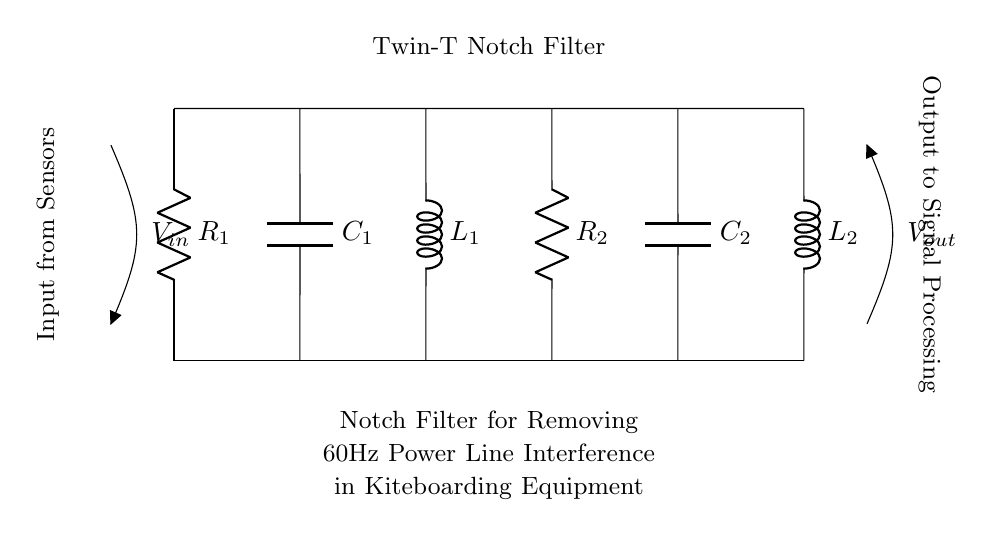What is the total number of components in the circuit? The circuit schematic shows six components: two resistors (R1, R2), two capacitors (C1, C2), and two inductors (L1, L2). Adding these gives a total of six components.
Answer: six What is the purpose of this circuit? The diagram is labeled "Notch Filter for Removing 60Hz Power Line Interference," indicating that its primary purpose is to filter out interference specifically at the frequency typical of power lines.
Answer: removing interference What is the input voltage symbol in the circuit? The input voltage in the schematic is represented by the symbol V_in, which is indicated at the left side of the circuit diagram.
Answer: V_in How many inductors are in this circuit? The circuit contains two inductors, as labeled L1 and L2, which are parts of the filter design.
Answer: two What type of filter is represented in this diagram? The circuit is specifically labeled as a "Twin-T Notch Filter," which designates its configuration for rejecting a specific frequency range.
Answer: Twin-T Notch Filter What is the output voltage label in the circuit? The output voltage is marked as V_out in the circuit diagram, which shows where the processed signal exits the filter.
Answer: V_out What components are used for frequency selection in the notch filter? In this configuration, the capacitor (C1, C2) and the inductors (L1, L2) are primarily responsible for the frequency selection, working together to create the notch effect.
Answer: capacitors and inductors 